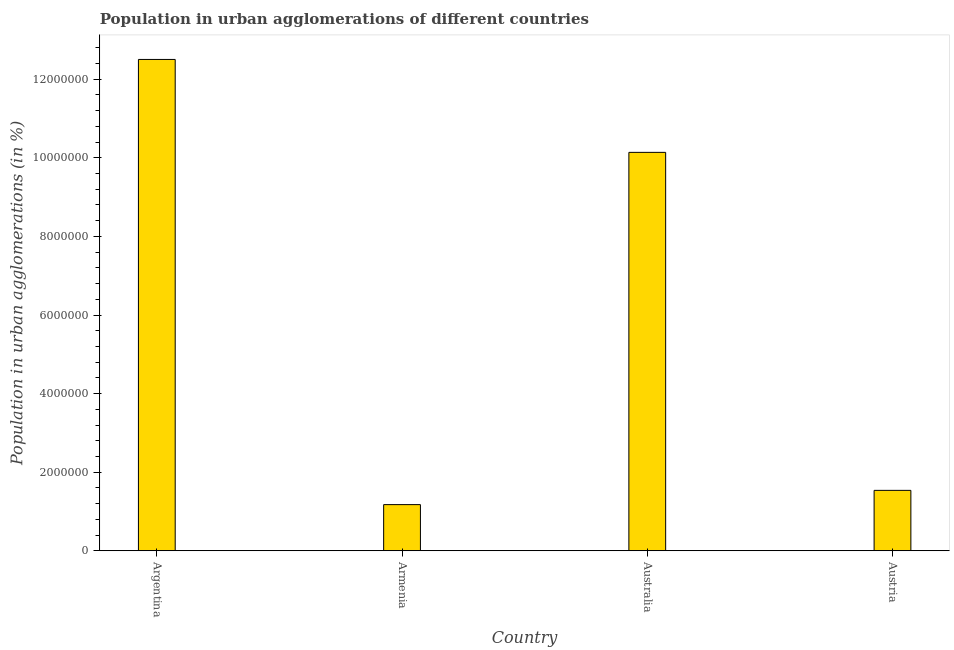What is the title of the graph?
Provide a short and direct response. Population in urban agglomerations of different countries. What is the label or title of the X-axis?
Your response must be concise. Country. What is the label or title of the Y-axis?
Offer a very short reply. Population in urban agglomerations (in %). What is the population in urban agglomerations in Armenia?
Provide a succinct answer. 1.17e+06. Across all countries, what is the maximum population in urban agglomerations?
Your answer should be compact. 1.25e+07. Across all countries, what is the minimum population in urban agglomerations?
Provide a short and direct response. 1.17e+06. In which country was the population in urban agglomerations minimum?
Your answer should be compact. Armenia. What is the sum of the population in urban agglomerations?
Keep it short and to the point. 2.54e+07. What is the difference between the population in urban agglomerations in Argentina and Australia?
Make the answer very short. 2.36e+06. What is the average population in urban agglomerations per country?
Offer a terse response. 6.34e+06. What is the median population in urban agglomerations?
Provide a short and direct response. 5.84e+06. In how many countries, is the population in urban agglomerations greater than 7600000 %?
Keep it short and to the point. 2. What is the ratio of the population in urban agglomerations in Armenia to that in Australia?
Ensure brevity in your answer.  0.12. What is the difference between the highest and the second highest population in urban agglomerations?
Your answer should be very brief. 2.36e+06. Is the sum of the population in urban agglomerations in Argentina and Australia greater than the maximum population in urban agglomerations across all countries?
Offer a terse response. Yes. What is the difference between the highest and the lowest population in urban agglomerations?
Keep it short and to the point. 1.13e+07. In how many countries, is the population in urban agglomerations greater than the average population in urban agglomerations taken over all countries?
Give a very brief answer. 2. How many bars are there?
Make the answer very short. 4. Are all the bars in the graph horizontal?
Make the answer very short. No. What is the Population in urban agglomerations (in %) in Argentina?
Keep it short and to the point. 1.25e+07. What is the Population in urban agglomerations (in %) of Armenia?
Provide a succinct answer. 1.17e+06. What is the Population in urban agglomerations (in %) of Australia?
Your answer should be very brief. 1.01e+07. What is the Population in urban agglomerations (in %) of Austria?
Keep it short and to the point. 1.54e+06. What is the difference between the Population in urban agglomerations (in %) in Argentina and Armenia?
Provide a succinct answer. 1.13e+07. What is the difference between the Population in urban agglomerations (in %) in Argentina and Australia?
Provide a succinct answer. 2.36e+06. What is the difference between the Population in urban agglomerations (in %) in Argentina and Austria?
Your response must be concise. 1.10e+07. What is the difference between the Population in urban agglomerations (in %) in Armenia and Australia?
Offer a terse response. -8.97e+06. What is the difference between the Population in urban agglomerations (in %) in Armenia and Austria?
Provide a short and direct response. -3.63e+05. What is the difference between the Population in urban agglomerations (in %) in Australia and Austria?
Your answer should be very brief. 8.60e+06. What is the ratio of the Population in urban agglomerations (in %) in Argentina to that in Armenia?
Provide a succinct answer. 10.64. What is the ratio of the Population in urban agglomerations (in %) in Argentina to that in Australia?
Your answer should be compact. 1.23. What is the ratio of the Population in urban agglomerations (in %) in Argentina to that in Austria?
Provide a short and direct response. 8.13. What is the ratio of the Population in urban agglomerations (in %) in Armenia to that in Australia?
Offer a very short reply. 0.12. What is the ratio of the Population in urban agglomerations (in %) in Armenia to that in Austria?
Your answer should be compact. 0.76. What is the ratio of the Population in urban agglomerations (in %) in Australia to that in Austria?
Your answer should be very brief. 6.59. 